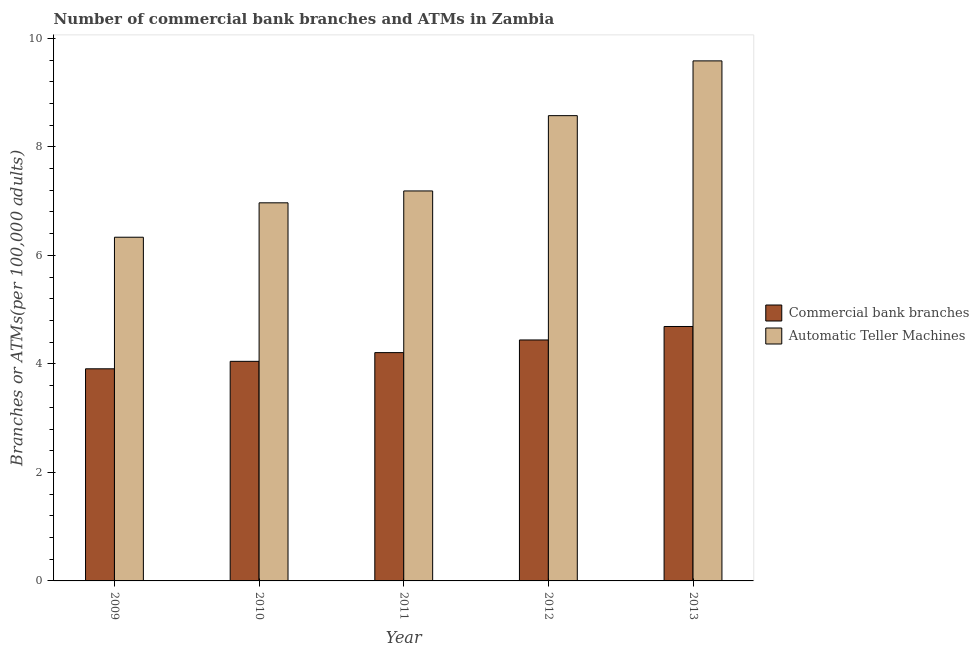How many bars are there on the 4th tick from the left?
Your response must be concise. 2. How many bars are there on the 3rd tick from the right?
Your answer should be compact. 2. What is the number of commercal bank branches in 2011?
Your answer should be compact. 4.21. Across all years, what is the maximum number of commercal bank branches?
Keep it short and to the point. 4.69. Across all years, what is the minimum number of atms?
Provide a short and direct response. 6.33. In which year was the number of atms maximum?
Ensure brevity in your answer.  2013. What is the total number of atms in the graph?
Ensure brevity in your answer.  38.65. What is the difference between the number of atms in 2009 and that in 2011?
Make the answer very short. -0.85. What is the difference between the number of atms in 2011 and the number of commercal bank branches in 2010?
Give a very brief answer. 0.22. What is the average number of commercal bank branches per year?
Provide a short and direct response. 4.26. In how many years, is the number of atms greater than 3.2?
Give a very brief answer. 5. What is the ratio of the number of atms in 2011 to that in 2012?
Ensure brevity in your answer.  0.84. Is the number of atms in 2010 less than that in 2011?
Provide a succinct answer. Yes. Is the difference between the number of atms in 2009 and 2011 greater than the difference between the number of commercal bank branches in 2009 and 2011?
Your response must be concise. No. What is the difference between the highest and the second highest number of commercal bank branches?
Give a very brief answer. 0.25. What is the difference between the highest and the lowest number of commercal bank branches?
Give a very brief answer. 0.78. What does the 1st bar from the left in 2012 represents?
Your answer should be very brief. Commercial bank branches. What does the 2nd bar from the right in 2013 represents?
Offer a terse response. Commercial bank branches. Are all the bars in the graph horizontal?
Your answer should be very brief. No. What is the difference between two consecutive major ticks on the Y-axis?
Provide a short and direct response. 2. Does the graph contain grids?
Give a very brief answer. No. What is the title of the graph?
Offer a very short reply. Number of commercial bank branches and ATMs in Zambia. Does "Investments" appear as one of the legend labels in the graph?
Give a very brief answer. No. What is the label or title of the Y-axis?
Offer a very short reply. Branches or ATMs(per 100,0 adults). What is the Branches or ATMs(per 100,000 adults) of Commercial bank branches in 2009?
Ensure brevity in your answer.  3.91. What is the Branches or ATMs(per 100,000 adults) in Automatic Teller Machines in 2009?
Offer a very short reply. 6.33. What is the Branches or ATMs(per 100,000 adults) of Commercial bank branches in 2010?
Offer a terse response. 4.05. What is the Branches or ATMs(per 100,000 adults) in Automatic Teller Machines in 2010?
Your answer should be very brief. 6.97. What is the Branches or ATMs(per 100,000 adults) in Commercial bank branches in 2011?
Make the answer very short. 4.21. What is the Branches or ATMs(per 100,000 adults) of Automatic Teller Machines in 2011?
Make the answer very short. 7.19. What is the Branches or ATMs(per 100,000 adults) of Commercial bank branches in 2012?
Keep it short and to the point. 4.44. What is the Branches or ATMs(per 100,000 adults) of Automatic Teller Machines in 2012?
Provide a short and direct response. 8.58. What is the Branches or ATMs(per 100,000 adults) of Commercial bank branches in 2013?
Make the answer very short. 4.69. What is the Branches or ATMs(per 100,000 adults) of Automatic Teller Machines in 2013?
Offer a very short reply. 9.59. Across all years, what is the maximum Branches or ATMs(per 100,000 adults) of Commercial bank branches?
Keep it short and to the point. 4.69. Across all years, what is the maximum Branches or ATMs(per 100,000 adults) of Automatic Teller Machines?
Ensure brevity in your answer.  9.59. Across all years, what is the minimum Branches or ATMs(per 100,000 adults) of Commercial bank branches?
Your answer should be very brief. 3.91. Across all years, what is the minimum Branches or ATMs(per 100,000 adults) in Automatic Teller Machines?
Offer a very short reply. 6.33. What is the total Branches or ATMs(per 100,000 adults) in Commercial bank branches in the graph?
Offer a terse response. 21.3. What is the total Branches or ATMs(per 100,000 adults) of Automatic Teller Machines in the graph?
Your response must be concise. 38.65. What is the difference between the Branches or ATMs(per 100,000 adults) of Commercial bank branches in 2009 and that in 2010?
Make the answer very short. -0.14. What is the difference between the Branches or ATMs(per 100,000 adults) in Automatic Teller Machines in 2009 and that in 2010?
Offer a terse response. -0.63. What is the difference between the Branches or ATMs(per 100,000 adults) in Commercial bank branches in 2009 and that in 2011?
Make the answer very short. -0.3. What is the difference between the Branches or ATMs(per 100,000 adults) in Automatic Teller Machines in 2009 and that in 2011?
Ensure brevity in your answer.  -0.85. What is the difference between the Branches or ATMs(per 100,000 adults) in Commercial bank branches in 2009 and that in 2012?
Your answer should be compact. -0.53. What is the difference between the Branches or ATMs(per 100,000 adults) of Automatic Teller Machines in 2009 and that in 2012?
Make the answer very short. -2.24. What is the difference between the Branches or ATMs(per 100,000 adults) of Commercial bank branches in 2009 and that in 2013?
Offer a very short reply. -0.78. What is the difference between the Branches or ATMs(per 100,000 adults) in Automatic Teller Machines in 2009 and that in 2013?
Your answer should be very brief. -3.25. What is the difference between the Branches or ATMs(per 100,000 adults) in Commercial bank branches in 2010 and that in 2011?
Your answer should be very brief. -0.16. What is the difference between the Branches or ATMs(per 100,000 adults) in Automatic Teller Machines in 2010 and that in 2011?
Provide a short and direct response. -0.22. What is the difference between the Branches or ATMs(per 100,000 adults) in Commercial bank branches in 2010 and that in 2012?
Your answer should be very brief. -0.39. What is the difference between the Branches or ATMs(per 100,000 adults) in Automatic Teller Machines in 2010 and that in 2012?
Your answer should be very brief. -1.61. What is the difference between the Branches or ATMs(per 100,000 adults) of Commercial bank branches in 2010 and that in 2013?
Give a very brief answer. -0.64. What is the difference between the Branches or ATMs(per 100,000 adults) in Automatic Teller Machines in 2010 and that in 2013?
Ensure brevity in your answer.  -2.62. What is the difference between the Branches or ATMs(per 100,000 adults) of Commercial bank branches in 2011 and that in 2012?
Your response must be concise. -0.23. What is the difference between the Branches or ATMs(per 100,000 adults) of Automatic Teller Machines in 2011 and that in 2012?
Your answer should be very brief. -1.39. What is the difference between the Branches or ATMs(per 100,000 adults) of Commercial bank branches in 2011 and that in 2013?
Your answer should be very brief. -0.48. What is the difference between the Branches or ATMs(per 100,000 adults) in Automatic Teller Machines in 2011 and that in 2013?
Provide a short and direct response. -2.4. What is the difference between the Branches or ATMs(per 100,000 adults) in Commercial bank branches in 2012 and that in 2013?
Your answer should be compact. -0.25. What is the difference between the Branches or ATMs(per 100,000 adults) in Automatic Teller Machines in 2012 and that in 2013?
Your answer should be very brief. -1.01. What is the difference between the Branches or ATMs(per 100,000 adults) of Commercial bank branches in 2009 and the Branches or ATMs(per 100,000 adults) of Automatic Teller Machines in 2010?
Your answer should be compact. -3.06. What is the difference between the Branches or ATMs(per 100,000 adults) in Commercial bank branches in 2009 and the Branches or ATMs(per 100,000 adults) in Automatic Teller Machines in 2011?
Give a very brief answer. -3.28. What is the difference between the Branches or ATMs(per 100,000 adults) in Commercial bank branches in 2009 and the Branches or ATMs(per 100,000 adults) in Automatic Teller Machines in 2012?
Ensure brevity in your answer.  -4.67. What is the difference between the Branches or ATMs(per 100,000 adults) of Commercial bank branches in 2009 and the Branches or ATMs(per 100,000 adults) of Automatic Teller Machines in 2013?
Offer a terse response. -5.68. What is the difference between the Branches or ATMs(per 100,000 adults) of Commercial bank branches in 2010 and the Branches or ATMs(per 100,000 adults) of Automatic Teller Machines in 2011?
Your answer should be compact. -3.14. What is the difference between the Branches or ATMs(per 100,000 adults) in Commercial bank branches in 2010 and the Branches or ATMs(per 100,000 adults) in Automatic Teller Machines in 2012?
Make the answer very short. -4.53. What is the difference between the Branches or ATMs(per 100,000 adults) of Commercial bank branches in 2010 and the Branches or ATMs(per 100,000 adults) of Automatic Teller Machines in 2013?
Make the answer very short. -5.54. What is the difference between the Branches or ATMs(per 100,000 adults) of Commercial bank branches in 2011 and the Branches or ATMs(per 100,000 adults) of Automatic Teller Machines in 2012?
Your answer should be compact. -4.37. What is the difference between the Branches or ATMs(per 100,000 adults) of Commercial bank branches in 2011 and the Branches or ATMs(per 100,000 adults) of Automatic Teller Machines in 2013?
Your response must be concise. -5.38. What is the difference between the Branches or ATMs(per 100,000 adults) of Commercial bank branches in 2012 and the Branches or ATMs(per 100,000 adults) of Automatic Teller Machines in 2013?
Your response must be concise. -5.14. What is the average Branches or ATMs(per 100,000 adults) in Commercial bank branches per year?
Keep it short and to the point. 4.26. What is the average Branches or ATMs(per 100,000 adults) of Automatic Teller Machines per year?
Provide a short and direct response. 7.73. In the year 2009, what is the difference between the Branches or ATMs(per 100,000 adults) in Commercial bank branches and Branches or ATMs(per 100,000 adults) in Automatic Teller Machines?
Make the answer very short. -2.43. In the year 2010, what is the difference between the Branches or ATMs(per 100,000 adults) of Commercial bank branches and Branches or ATMs(per 100,000 adults) of Automatic Teller Machines?
Offer a very short reply. -2.92. In the year 2011, what is the difference between the Branches or ATMs(per 100,000 adults) of Commercial bank branches and Branches or ATMs(per 100,000 adults) of Automatic Teller Machines?
Your answer should be very brief. -2.98. In the year 2012, what is the difference between the Branches or ATMs(per 100,000 adults) of Commercial bank branches and Branches or ATMs(per 100,000 adults) of Automatic Teller Machines?
Offer a very short reply. -4.13. In the year 2013, what is the difference between the Branches or ATMs(per 100,000 adults) in Commercial bank branches and Branches or ATMs(per 100,000 adults) in Automatic Teller Machines?
Your response must be concise. -4.9. What is the ratio of the Branches or ATMs(per 100,000 adults) of Automatic Teller Machines in 2009 to that in 2010?
Ensure brevity in your answer.  0.91. What is the ratio of the Branches or ATMs(per 100,000 adults) of Commercial bank branches in 2009 to that in 2011?
Offer a terse response. 0.93. What is the ratio of the Branches or ATMs(per 100,000 adults) of Automatic Teller Machines in 2009 to that in 2011?
Ensure brevity in your answer.  0.88. What is the ratio of the Branches or ATMs(per 100,000 adults) of Commercial bank branches in 2009 to that in 2012?
Keep it short and to the point. 0.88. What is the ratio of the Branches or ATMs(per 100,000 adults) in Automatic Teller Machines in 2009 to that in 2012?
Offer a terse response. 0.74. What is the ratio of the Branches or ATMs(per 100,000 adults) of Commercial bank branches in 2009 to that in 2013?
Make the answer very short. 0.83. What is the ratio of the Branches or ATMs(per 100,000 adults) in Automatic Teller Machines in 2009 to that in 2013?
Provide a succinct answer. 0.66. What is the ratio of the Branches or ATMs(per 100,000 adults) in Commercial bank branches in 2010 to that in 2011?
Your answer should be compact. 0.96. What is the ratio of the Branches or ATMs(per 100,000 adults) in Automatic Teller Machines in 2010 to that in 2011?
Keep it short and to the point. 0.97. What is the ratio of the Branches or ATMs(per 100,000 adults) in Commercial bank branches in 2010 to that in 2012?
Give a very brief answer. 0.91. What is the ratio of the Branches or ATMs(per 100,000 adults) of Automatic Teller Machines in 2010 to that in 2012?
Give a very brief answer. 0.81. What is the ratio of the Branches or ATMs(per 100,000 adults) in Commercial bank branches in 2010 to that in 2013?
Provide a succinct answer. 0.86. What is the ratio of the Branches or ATMs(per 100,000 adults) of Automatic Teller Machines in 2010 to that in 2013?
Keep it short and to the point. 0.73. What is the ratio of the Branches or ATMs(per 100,000 adults) in Commercial bank branches in 2011 to that in 2012?
Offer a terse response. 0.95. What is the ratio of the Branches or ATMs(per 100,000 adults) in Automatic Teller Machines in 2011 to that in 2012?
Your response must be concise. 0.84. What is the ratio of the Branches or ATMs(per 100,000 adults) of Commercial bank branches in 2011 to that in 2013?
Ensure brevity in your answer.  0.9. What is the ratio of the Branches or ATMs(per 100,000 adults) of Automatic Teller Machines in 2011 to that in 2013?
Provide a succinct answer. 0.75. What is the ratio of the Branches or ATMs(per 100,000 adults) in Commercial bank branches in 2012 to that in 2013?
Your answer should be compact. 0.95. What is the ratio of the Branches or ATMs(per 100,000 adults) of Automatic Teller Machines in 2012 to that in 2013?
Your response must be concise. 0.89. What is the difference between the highest and the second highest Branches or ATMs(per 100,000 adults) in Commercial bank branches?
Make the answer very short. 0.25. What is the difference between the highest and the second highest Branches or ATMs(per 100,000 adults) in Automatic Teller Machines?
Your answer should be compact. 1.01. What is the difference between the highest and the lowest Branches or ATMs(per 100,000 adults) in Commercial bank branches?
Keep it short and to the point. 0.78. What is the difference between the highest and the lowest Branches or ATMs(per 100,000 adults) of Automatic Teller Machines?
Keep it short and to the point. 3.25. 